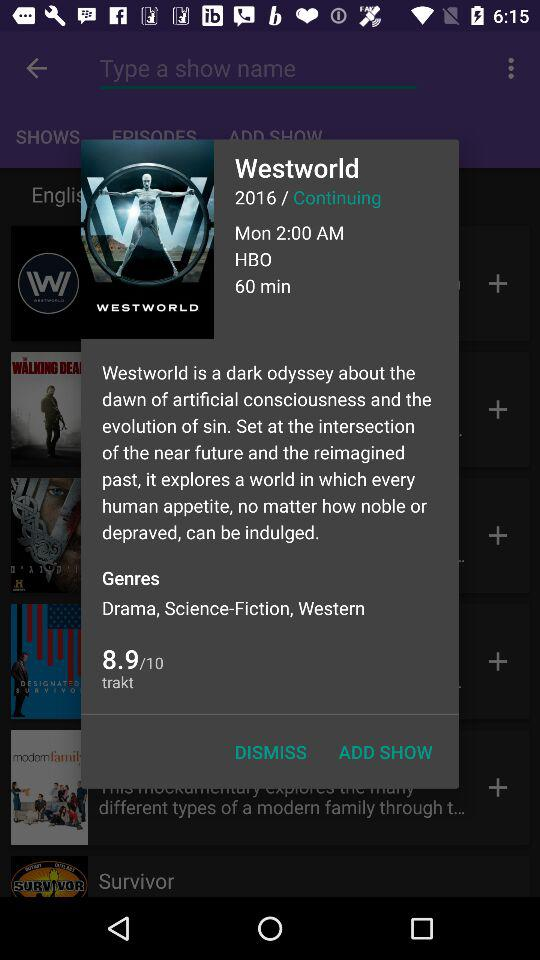What is the duration of the series? The duration is 60 minutes. 